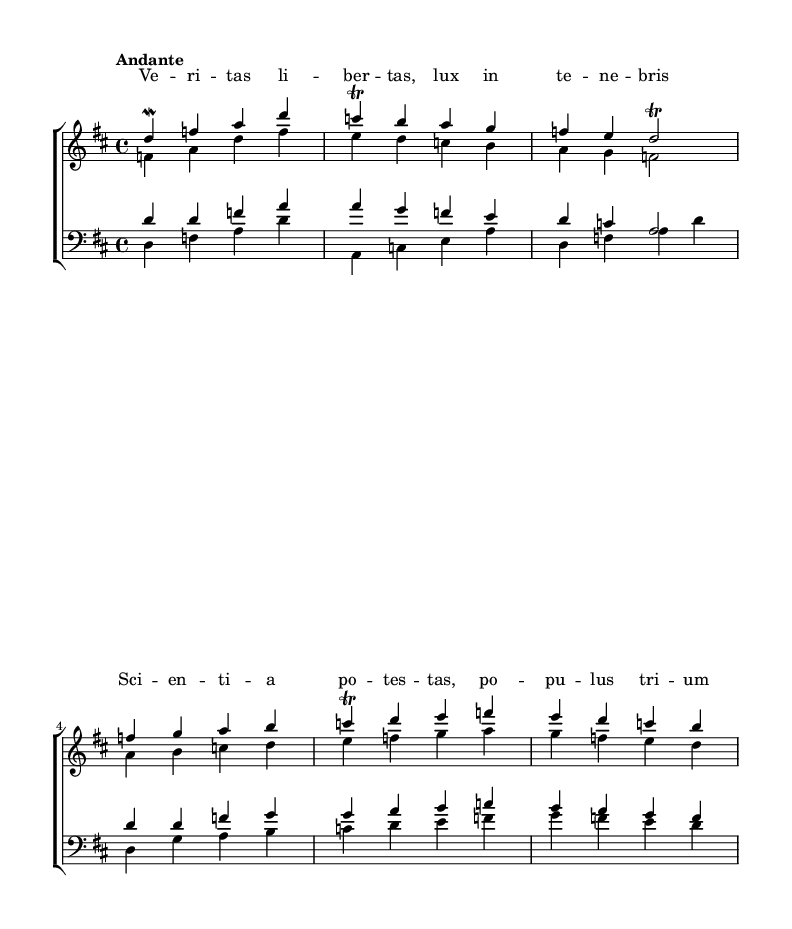What is the key signature of this music? The key signature is D major, which has two sharps (F# and C#).
Answer: D major What is the time signature of this piece? The time signature is 4/4, indicating four beats per measure.
Answer: 4/4 What is the tempo marking for this piece? The tempo marking is "Andante", which suggests a moderate pace.
Answer: Andante How many voices are there in the choral work? There are four voices: soprano, alto, tenor, and bass.
Answer: Four What is the main theme expressed in the lyrics? The lyrics express the themes of liberty and knowledge, emphasizing the power of transparency and information.
Answer: Liberty and knowledge What is the highest note sung by the sopranos? The highest note in the soprano line is D in the fourth octave.
Answer: D in the fourth octave How is the music structured in relation to a typical Baroque piece? This work features a clear four-part harmony typical of Baroque choral compositions with distinct voice lines.
Answer: Four-part harmony 